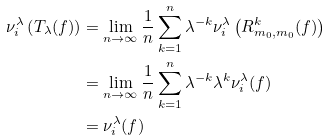<formula> <loc_0><loc_0><loc_500><loc_500>\nu _ { i } ^ { \lambda } \left ( T _ { \lambda } ( f ) \right ) & = \lim _ { n \rightarrow \infty } \frac { 1 } { n } \sum _ { k = 1 } ^ { n } \lambda ^ { - k } \nu _ { i } ^ { \lambda } \left ( R _ { m _ { 0 } , m _ { 0 } } ^ { k } ( f ) \right ) \\ & = \lim _ { n \rightarrow \infty } \frac { 1 } { n } \sum _ { k = 1 } ^ { n } \lambda ^ { - k } \lambda ^ { k } \nu _ { i } ^ { \lambda } ( f ) \\ & = \nu _ { i } ^ { \lambda } ( f )</formula> 